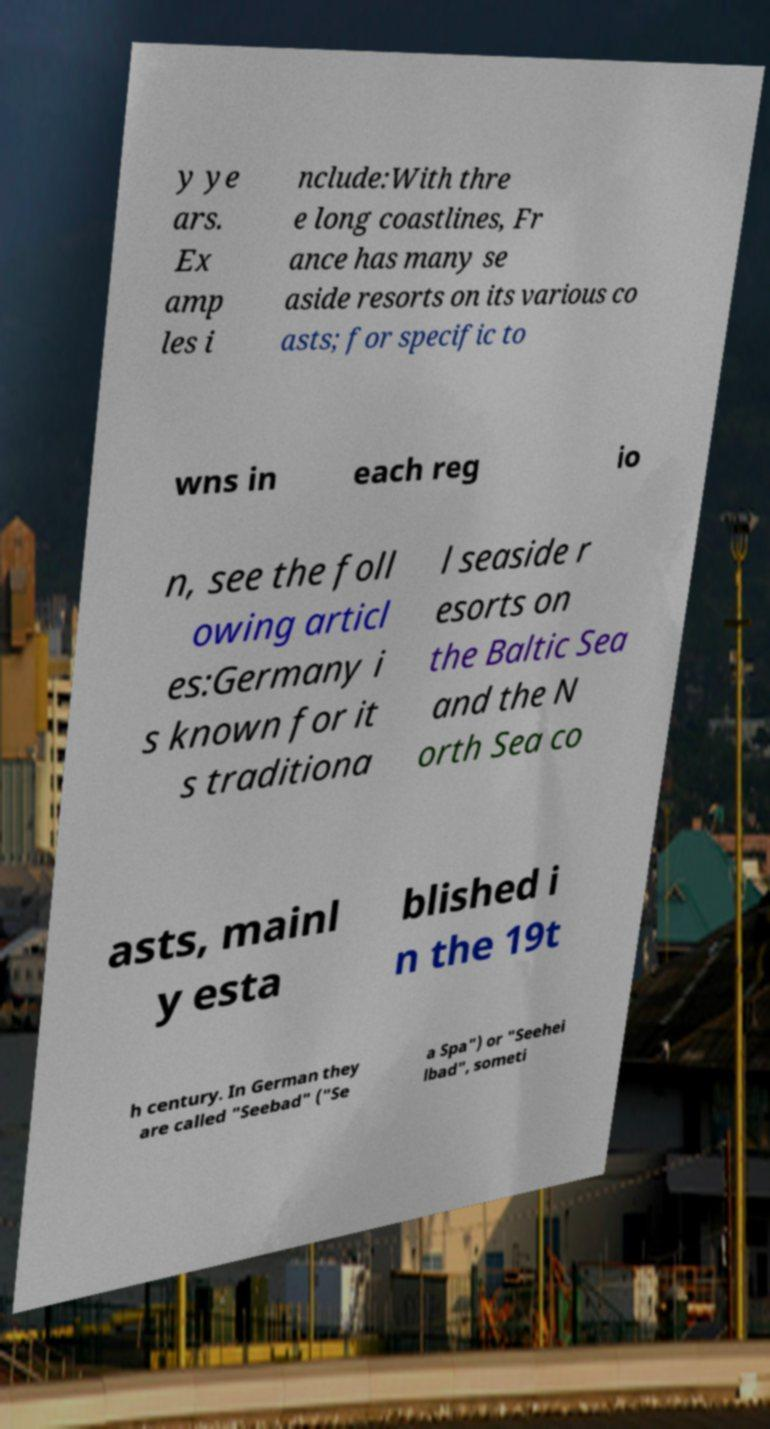Could you extract and type out the text from this image? y ye ars. Ex amp les i nclude:With thre e long coastlines, Fr ance has many se aside resorts on its various co asts; for specific to wns in each reg io n, see the foll owing articl es:Germany i s known for it s traditiona l seaside r esorts on the Baltic Sea and the N orth Sea co asts, mainl y esta blished i n the 19t h century. In German they are called "Seebad" ("Se a Spa") or "Seehei lbad", someti 